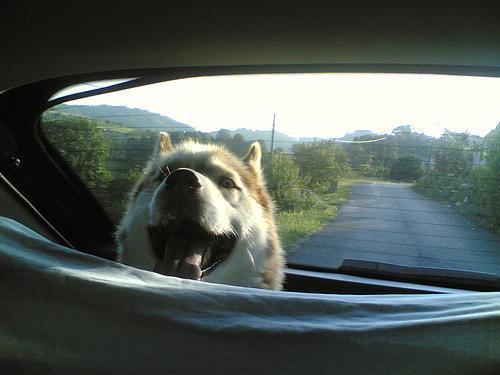How many people are playing tennis?
Give a very brief answer. 0. 